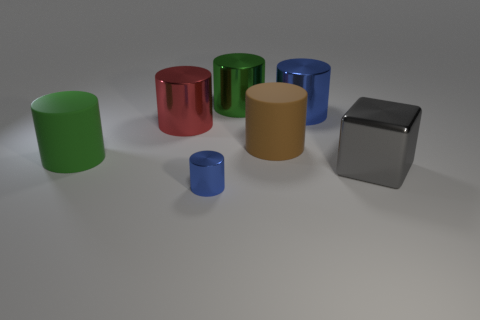There is a big green cylinder that is behind the green thing in front of the big blue metal cylinder; how many large metal cubes are to the left of it?
Ensure brevity in your answer.  0. Is the color of the big cylinder behind the big blue metal cylinder the same as the large shiny cylinder that is on the right side of the large brown matte thing?
Offer a very short reply. No. There is a big cylinder that is both left of the large green metallic cylinder and in front of the large red cylinder; what color is it?
Offer a very short reply. Green. How many blue metal objects have the same size as the brown thing?
Provide a short and direct response. 1. There is a large brown rubber thing that is to the right of the green cylinder on the left side of the tiny thing; what is its shape?
Ensure brevity in your answer.  Cylinder. There is a matte object in front of the large brown thing that is behind the large green rubber cylinder to the left of the big blue cylinder; what shape is it?
Provide a short and direct response. Cylinder. How many brown matte things have the same shape as the green matte object?
Keep it short and to the point. 1. There is a blue shiny object that is on the right side of the tiny metallic thing; how many blue objects are behind it?
Offer a very short reply. 0. What number of matte objects are either red things or blue cylinders?
Ensure brevity in your answer.  0. Are there any cylinders made of the same material as the big block?
Your answer should be compact. Yes. 